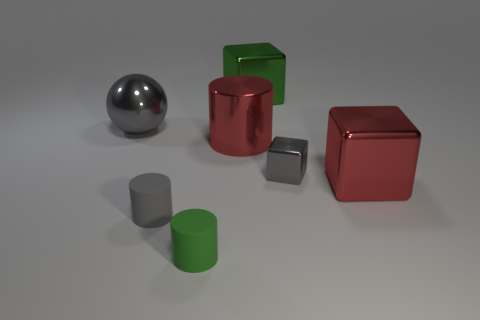There is a metallic thing that is the same shape as the green rubber object; what is its color?
Your response must be concise. Red. What is the size of the green cylinder?
Ensure brevity in your answer.  Small. What number of green matte objects are the same size as the green metallic cube?
Keep it short and to the point. 0. Is the color of the large shiny sphere the same as the tiny metallic object?
Ensure brevity in your answer.  Yes. Are the big thing that is on the right side of the tiny shiny cube and the green thing that is behind the gray matte object made of the same material?
Offer a terse response. Yes. Are there more small spheres than green cylinders?
Your answer should be compact. No. Is there any other thing that is the same color as the large sphere?
Offer a terse response. Yes. Do the gray cylinder and the ball have the same material?
Give a very brief answer. No. Are there fewer purple rubber spheres than big objects?
Your answer should be very brief. Yes. Is the shape of the tiny metallic object the same as the big green object?
Your answer should be very brief. Yes. 